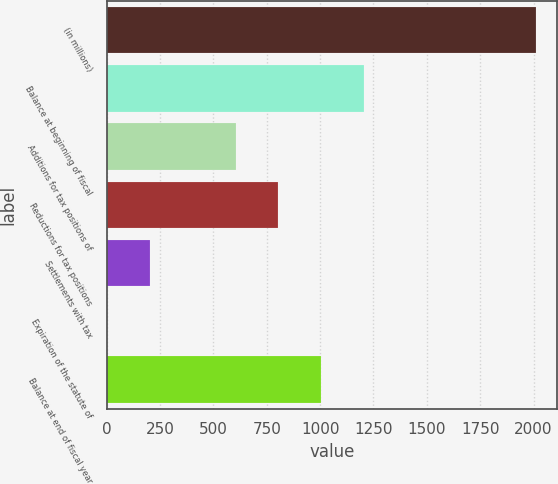Convert chart. <chart><loc_0><loc_0><loc_500><loc_500><bar_chart><fcel>(in millions)<fcel>Balance at beginning of fiscal<fcel>Additions for tax positions of<fcel>Reductions for tax positions<fcel>Settlements with tax<fcel>Expiration of the statute of<fcel>Balance at end of fiscal year<nl><fcel>2010<fcel>1206.4<fcel>603.7<fcel>804.6<fcel>201.9<fcel>1<fcel>1005.5<nl></chart> 